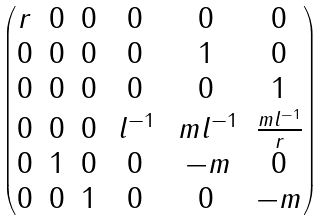Convert formula to latex. <formula><loc_0><loc_0><loc_500><loc_500>\begin{pmatrix} r & 0 & 0 & 0 & 0 & 0 \\ 0 & 0 & 0 & 0 & 1 & 0 \\ 0 & 0 & 0 & 0 & 0 & 1 \\ 0 & 0 & 0 & \, l ^ { - 1 } & \, m l ^ { - 1 } & \frac { m l ^ { - 1 } } { r } \\ 0 & 1 & 0 & 0 & \, - m & 0 \\ 0 & 0 & 1 & 0 & 0 & - m \end{pmatrix}</formula> 